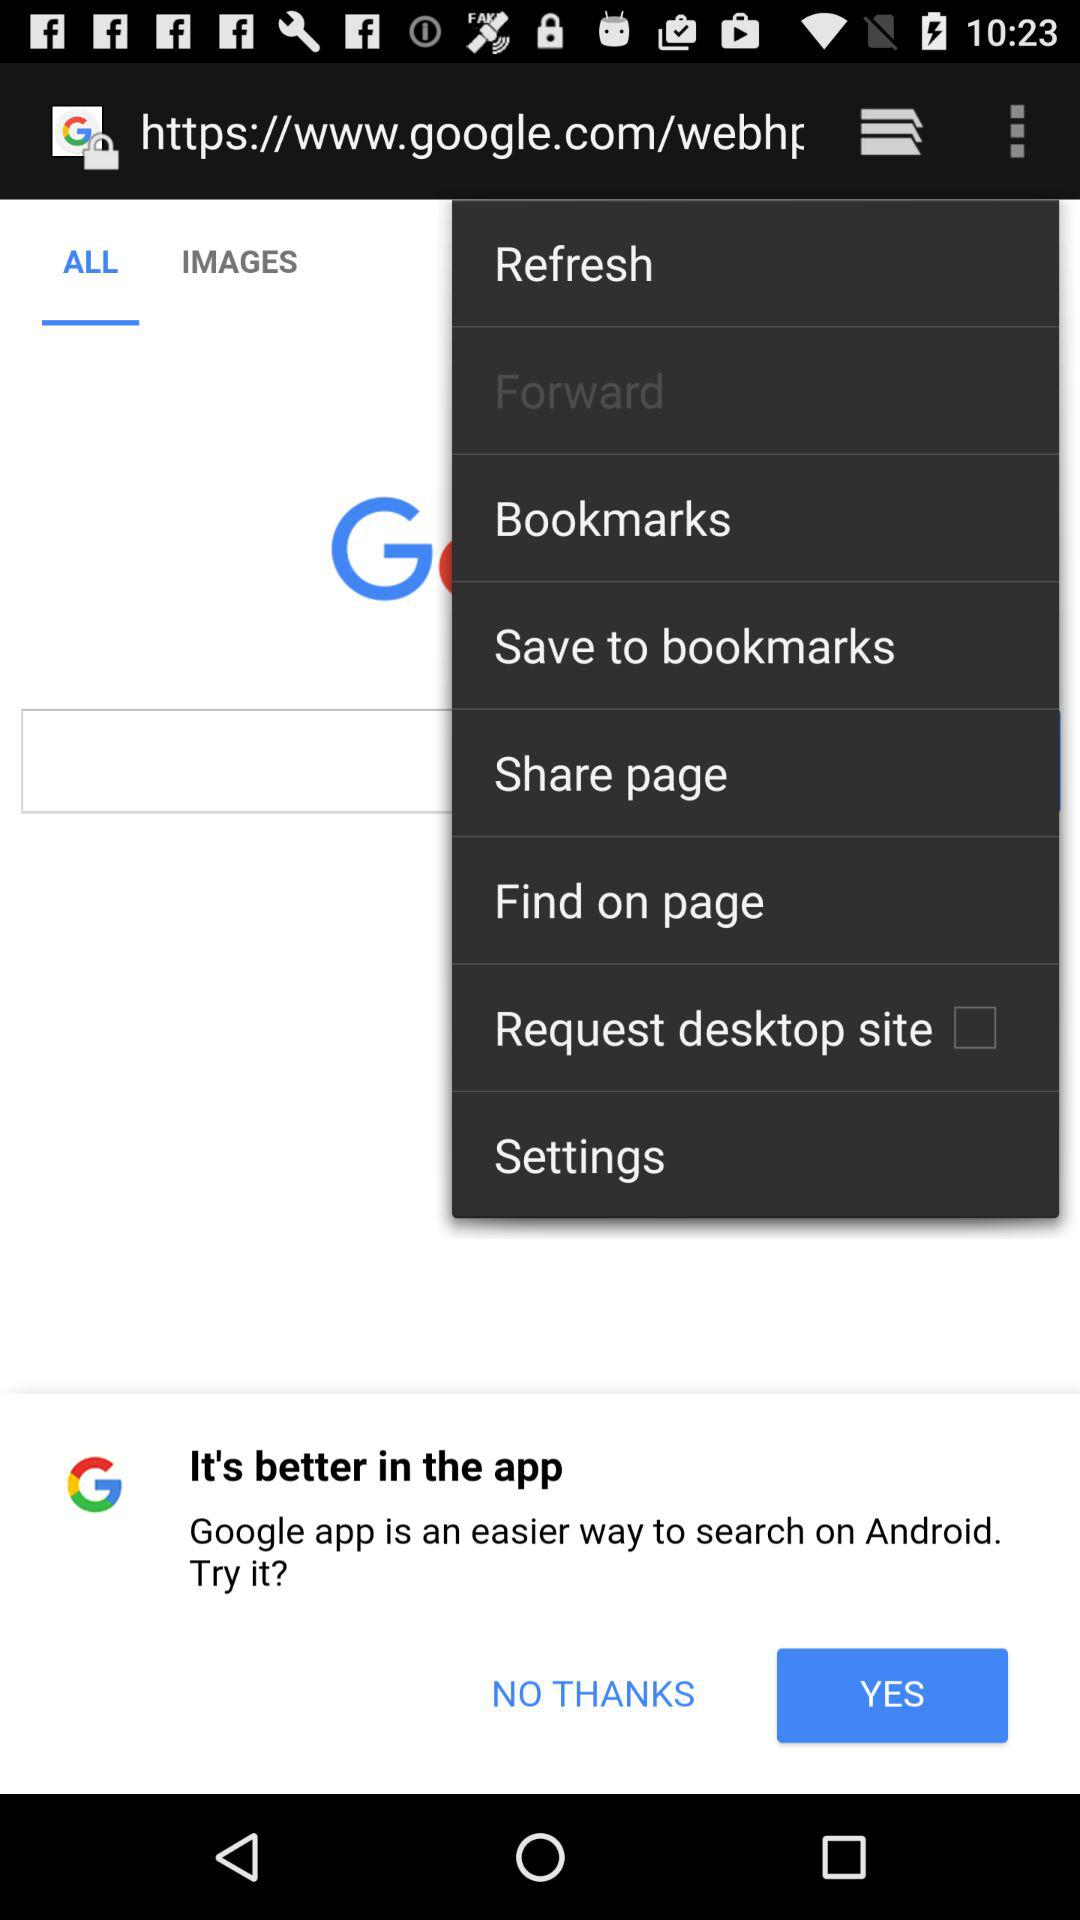Which tab is selected? The selected tab is "ALL". 